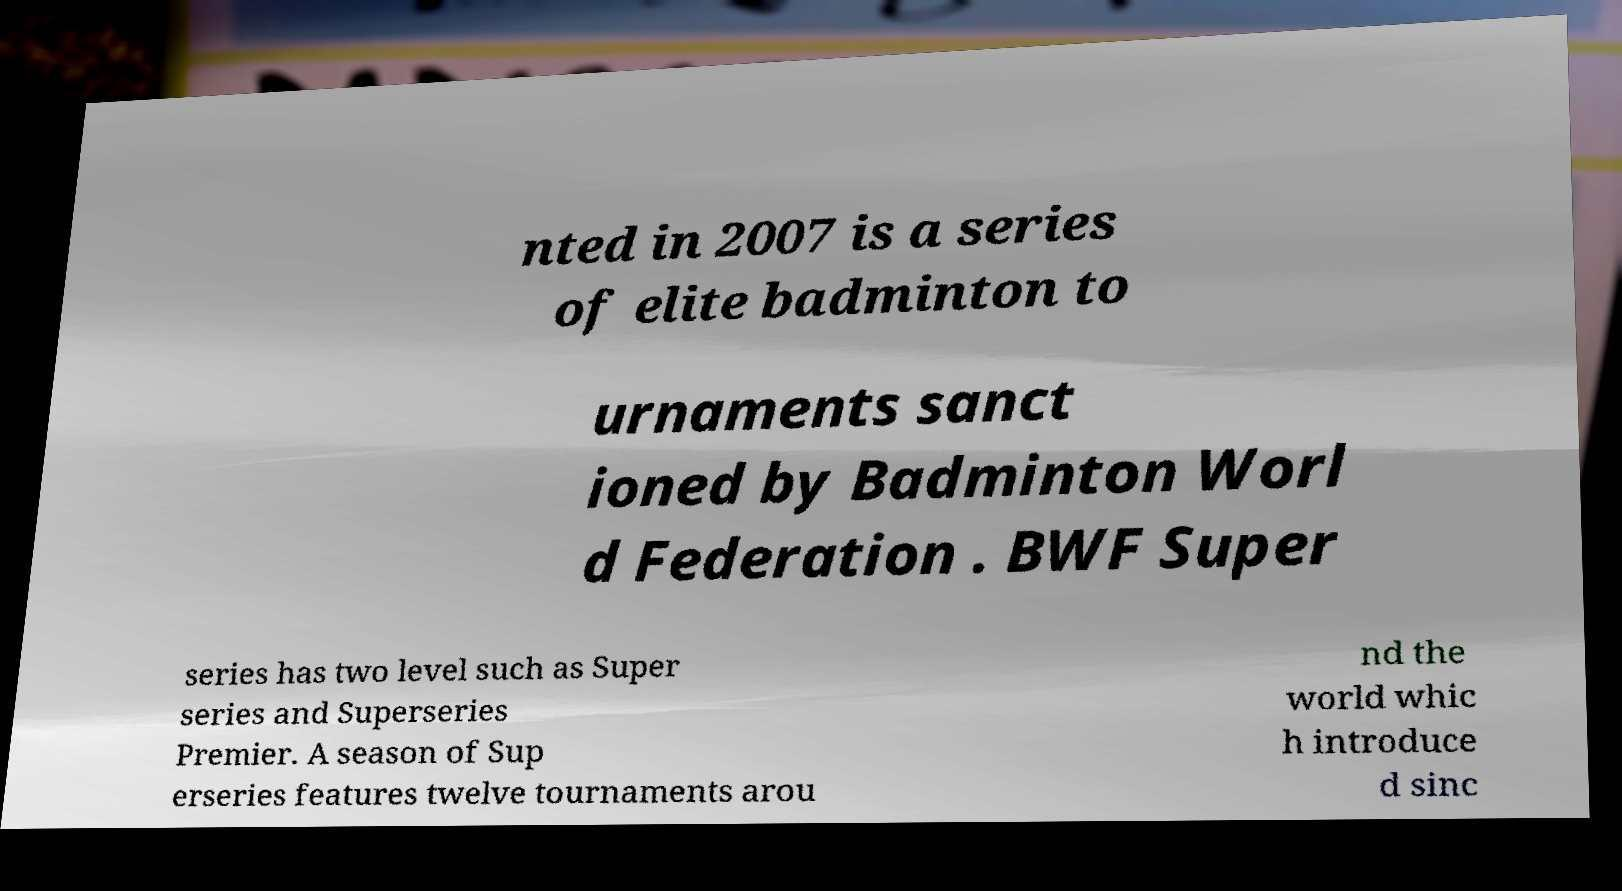I need the written content from this picture converted into text. Can you do that? nted in 2007 is a series of elite badminton to urnaments sanct ioned by Badminton Worl d Federation . BWF Super series has two level such as Super series and Superseries Premier. A season of Sup erseries features twelve tournaments arou nd the world whic h introduce d sinc 